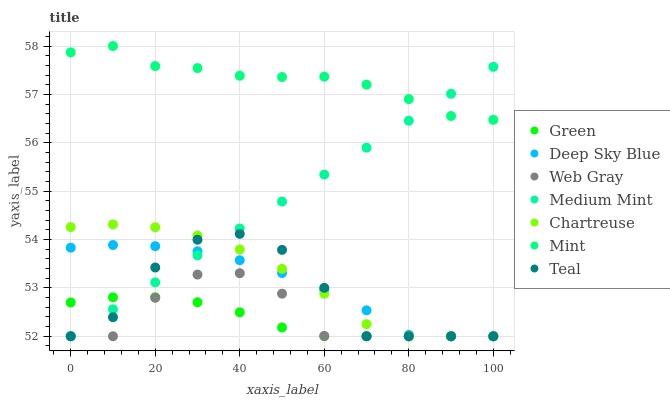Does Green have the minimum area under the curve?
Answer yes or no. Yes. Does Mint have the maximum area under the curve?
Answer yes or no. Yes. Does Web Gray have the minimum area under the curve?
Answer yes or no. No. Does Web Gray have the maximum area under the curve?
Answer yes or no. No. Is Medium Mint the smoothest?
Answer yes or no. Yes. Is Teal the roughest?
Answer yes or no. Yes. Is Web Gray the smoothest?
Answer yes or no. No. Is Web Gray the roughest?
Answer yes or no. No. Does Medium Mint have the lowest value?
Answer yes or no. Yes. Does Mint have the lowest value?
Answer yes or no. No. Does Mint have the highest value?
Answer yes or no. Yes. Does Web Gray have the highest value?
Answer yes or no. No. Is Chartreuse less than Mint?
Answer yes or no. Yes. Is Mint greater than Web Gray?
Answer yes or no. Yes. Does Chartreuse intersect Teal?
Answer yes or no. Yes. Is Chartreuse less than Teal?
Answer yes or no. No. Is Chartreuse greater than Teal?
Answer yes or no. No. Does Chartreuse intersect Mint?
Answer yes or no. No. 